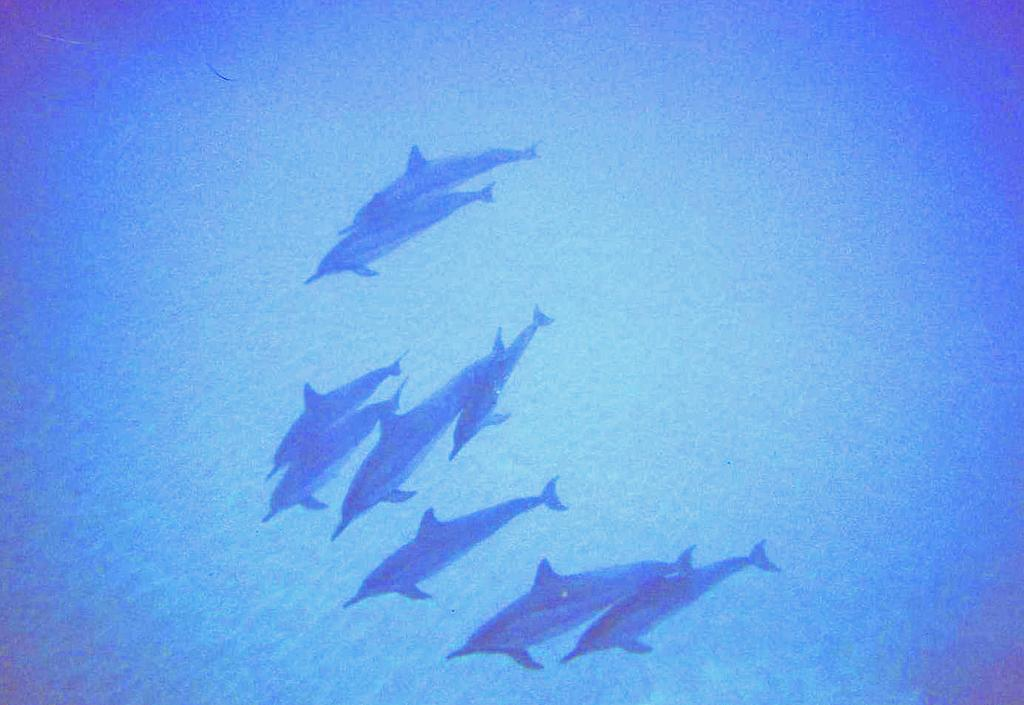What type of animals are in the image? There are many dolphins in the image. Where are the dolphins located? The dolphins are in the water. What type of yam is the dolphin holding in its pocket in the image? There is no yam or pocket present in the image, as dolphins do not have pockets and are not holding any yams. 